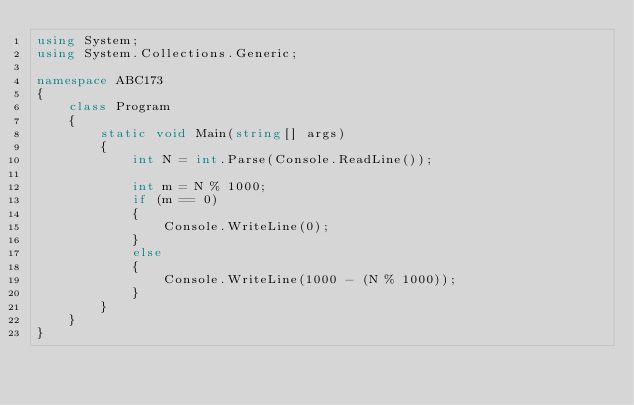<code> <loc_0><loc_0><loc_500><loc_500><_C#_>using System;
using System.Collections.Generic;

namespace ABC173
{
    class Program
    {
        static void Main(string[] args)
        {
            int N = int.Parse(Console.ReadLine());

            int m = N % 1000;
            if (m == 0)
            {
                Console.WriteLine(0);
            }
            else
            {
                Console.WriteLine(1000 - (N % 1000));
            }
        }
    }
}
</code> 